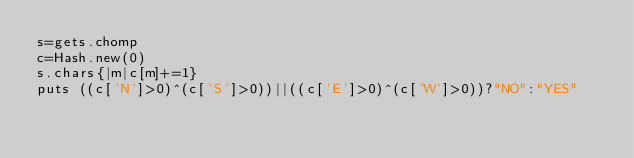Convert code to text. <code><loc_0><loc_0><loc_500><loc_500><_Ruby_>s=gets.chomp
c=Hash.new(0)
s.chars{|m|c[m]+=1}
puts ((c['N']>0)^(c['S']>0))||((c['E']>0)^(c['W']>0))?"NO":"YES"</code> 